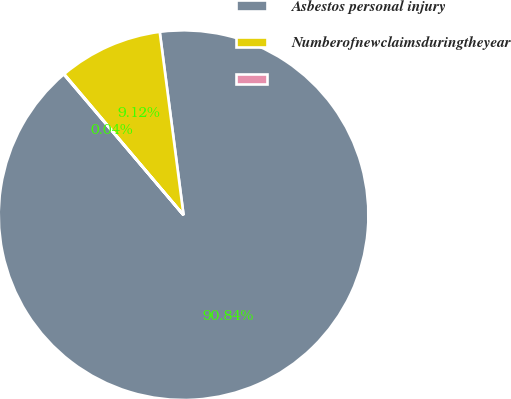<chart> <loc_0><loc_0><loc_500><loc_500><pie_chart><fcel>Asbestos personal injury<fcel>Numberofnewclaimsduringtheyear<fcel>Unnamed: 2<nl><fcel>90.85%<fcel>9.12%<fcel>0.04%<nl></chart> 